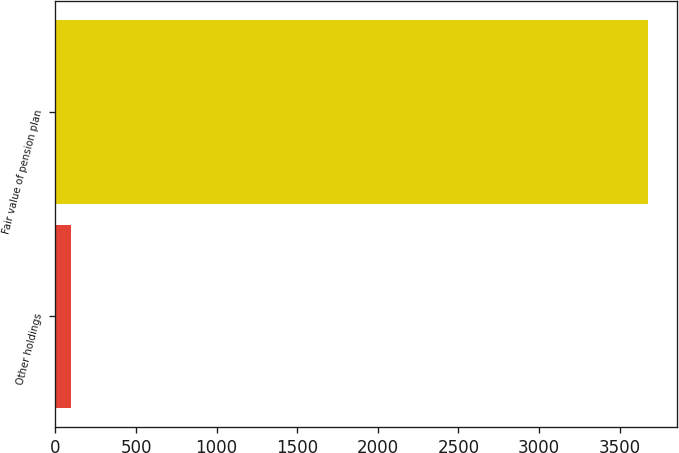Convert chart to OTSL. <chart><loc_0><loc_0><loc_500><loc_500><bar_chart><fcel>Other holdings<fcel>Fair value of pension plan<nl><fcel>96<fcel>3673<nl></chart> 